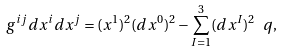Convert formula to latex. <formula><loc_0><loc_0><loc_500><loc_500>g ^ { i j } d x ^ { i } d x ^ { j } = ( x ^ { 1 } ) ^ { 2 } ( d x ^ { 0 } ) ^ { 2 } - \sum _ { I = 1 } ^ { 3 } ( d x ^ { I } ) ^ { 2 } \ q ,</formula> 